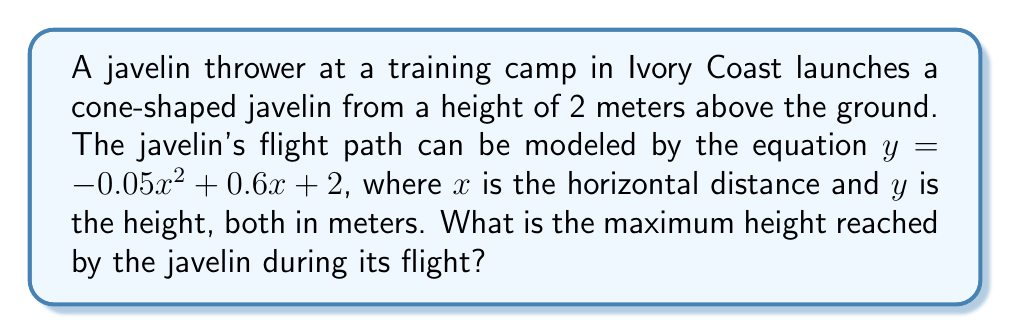Solve this math problem. To find the maximum height of the javelin's flight path, we need to follow these steps:

1) The flight path is described by a quadratic equation in the form $y = ax^2 + bx + c$, where:
   $a = -0.05$
   $b = 0.6$
   $c = 2$

2) For a quadratic function, the x-coordinate of the vertex represents the point where the maximum height is reached. This can be calculated using the formula:

   $x = -\frac{b}{2a}$

3) Substituting our values:

   $x = -\frac{0.6}{2(-0.05)} = -\frac{0.6}{-0.1} = 6$

4) To find the maximum height, we substitute this x-value back into our original equation:

   $y = -0.05(6)^2 + 0.6(6) + 2$

5) Simplifying:
   $y = -0.05(36) + 3.6 + 2$
   $y = -1.8 + 3.6 + 2$
   $y = 3.8$

Therefore, the maximum height reached by the javelin is 3.8 meters.
Answer: 3.8 meters 